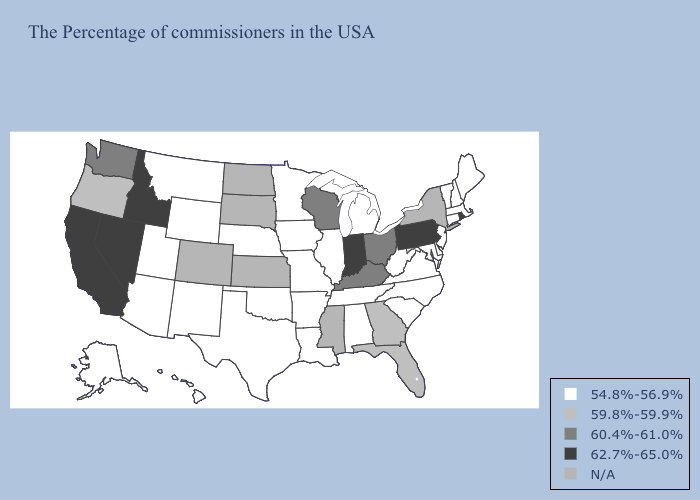Name the states that have a value in the range 62.7%-65.0%?
Quick response, please. Rhode Island, Pennsylvania, Indiana, Idaho, Nevada, California. Does Georgia have the lowest value in the USA?
Keep it brief. No. What is the highest value in states that border Wisconsin?
Be succinct. 54.8%-56.9%. Name the states that have a value in the range 62.7%-65.0%?
Concise answer only. Rhode Island, Pennsylvania, Indiana, Idaho, Nevada, California. What is the value of South Carolina?
Quick response, please. 54.8%-56.9%. What is the value of Massachusetts?
Short answer required. 54.8%-56.9%. What is the value of Massachusetts?
Keep it brief. 54.8%-56.9%. What is the lowest value in states that border Wisconsin?
Be succinct. 54.8%-56.9%. Name the states that have a value in the range 62.7%-65.0%?
Concise answer only. Rhode Island, Pennsylvania, Indiana, Idaho, Nevada, California. Does Utah have the highest value in the USA?
Give a very brief answer. No. Name the states that have a value in the range N/A?
Be succinct. New York, Mississippi, Kansas, South Dakota, North Dakota, Colorado. Name the states that have a value in the range 60.4%-61.0%?
Write a very short answer. Ohio, Kentucky, Wisconsin, Washington. Name the states that have a value in the range 62.7%-65.0%?
Concise answer only. Rhode Island, Pennsylvania, Indiana, Idaho, Nevada, California. What is the value of Utah?
Short answer required. 54.8%-56.9%. 